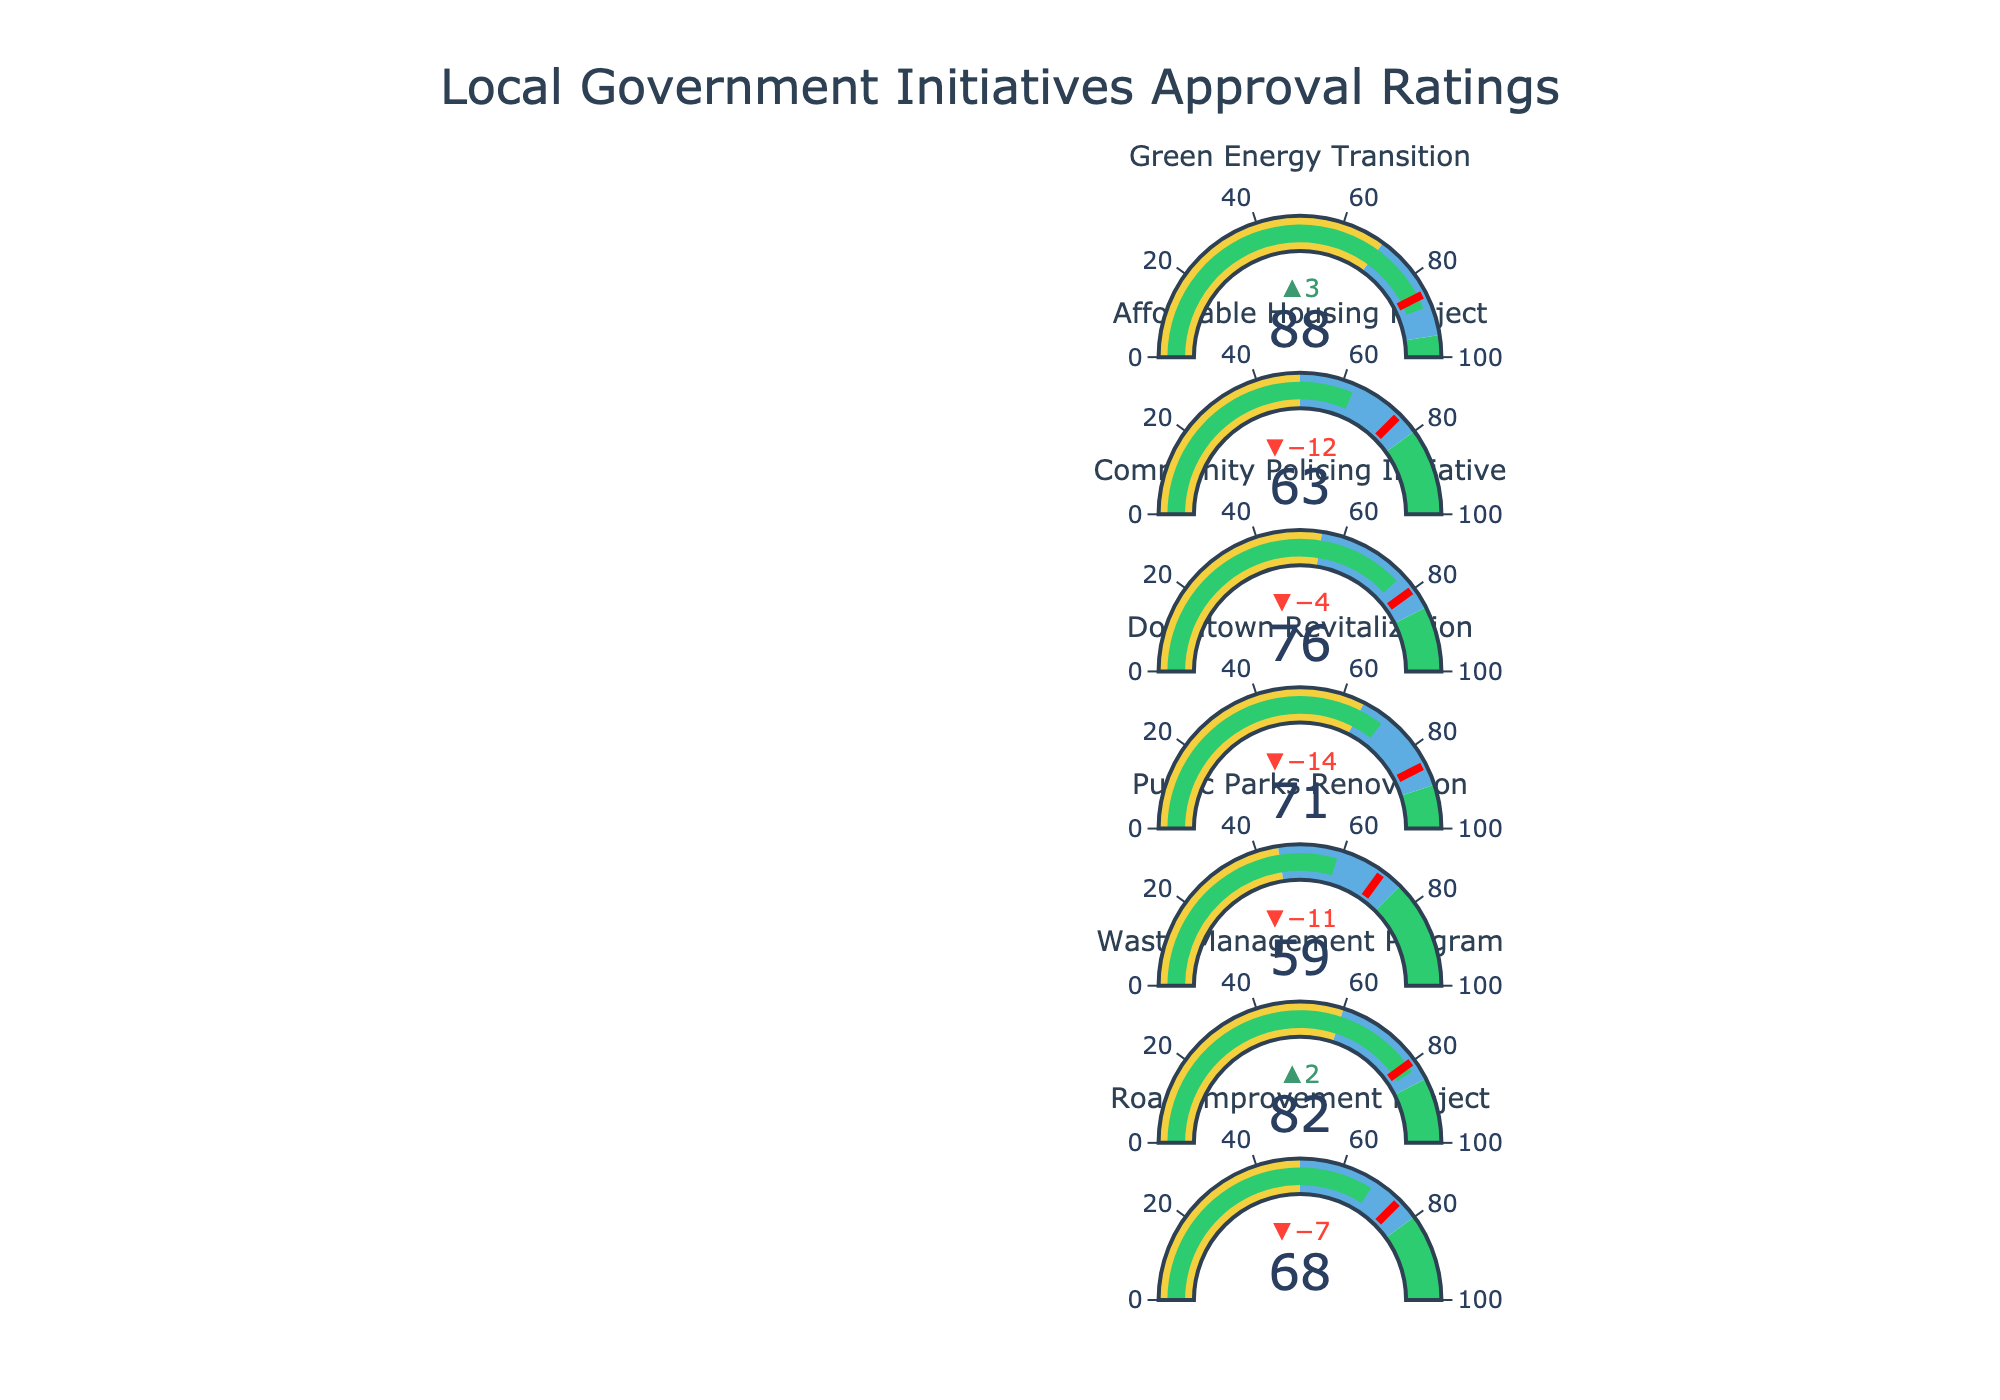What is the title of the chart? The title of the chart is displayed prominently at the top and reads, "Local Government Initiatives Approval Ratings".
Answer: Local Government Initiatives Approval Ratings How many initiatives are presented in the chart? By visually counting the number of bullet charts or initiatives listed, we can see that there are seven initiatives in total.
Answer: 7 What is the current approval rating for the Green Energy Transition initiative? To find this, locate the bullet chart for the Green Energy Transition initiative and read the value indicated by the green bar. It shows a current approval rating of 88.
Answer: 88 Is the Community Policing Initiative meeting its goal? Check the current approval rating against the goal for the Community Policing Initiative. The current approval rating is 76 and the goal is 80, which shows it is not meeting its goal.
Answer: No Which initiative has the largest discrepancy between the current approval and the goal? Review each initiative's current approval and goal, calculate the differences, and find the largest one. For Downtown Revitalization, the difference is 85 - 71 = 14, which is the largest discrepancy.
Answer: Downtown Revitalization Which initiative has the highest current approval rating? By looking at all the green bars, the highest value is for the Green Energy Transition initiative, which is 88.
Answer: Green Energy Transition What is the color used to indicate an approval rating that meets or exceeds the preset goal? The color used for approval ratings meeting or exceeding goals is green. We can see this color associated with values reaching the threshold.
Answer: Green Are there any initiatives where the current approval falls into the "Poor" category? The "Poor" category colors on the gauge are red segments. None of the bullet charts have their green bars falling into these segments, indicating no initiatives fall into the "Poor" category.
Answer: No Which initiative is closest to its goal? Check the difference between current approval and the goal for each initiative and find the smallest one. The Waste Management Program is closest to its goal with an approval of 82 versus a goal of 80, a difference of 2.
Answer: Waste Management Program What is the overall goal range for these initiatives? Review the goal values for all initiatives to identify the lowest and highest goal values. The range is from 70 (Public Parks Renovation) to 90 (Downtown Revitalization).
Answer: 70 to 90 